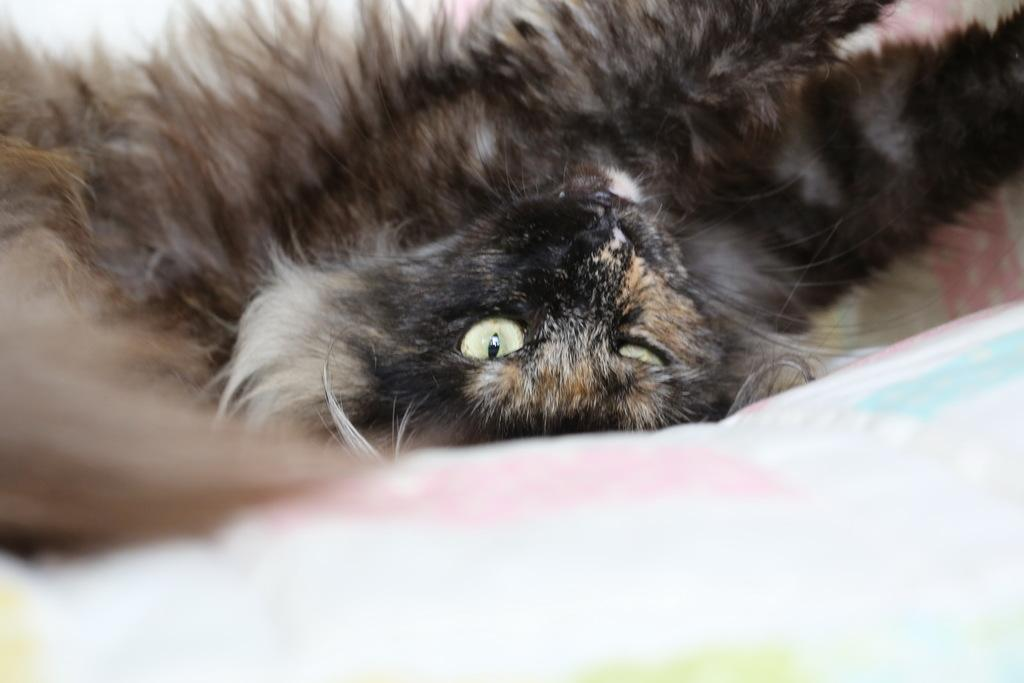What animal is in the image? There is a cat in the image. Where is the cat located in the image? The cat is in the middle of the image. What colors can be seen on the cat in the image? The cat is black and brown in color. How many feet can be seen in the image? There are no feet visible in the image; it features a cat. What type of smell can be detected in the image? There is no indication of any smell in the image, as it is a visual medium. 